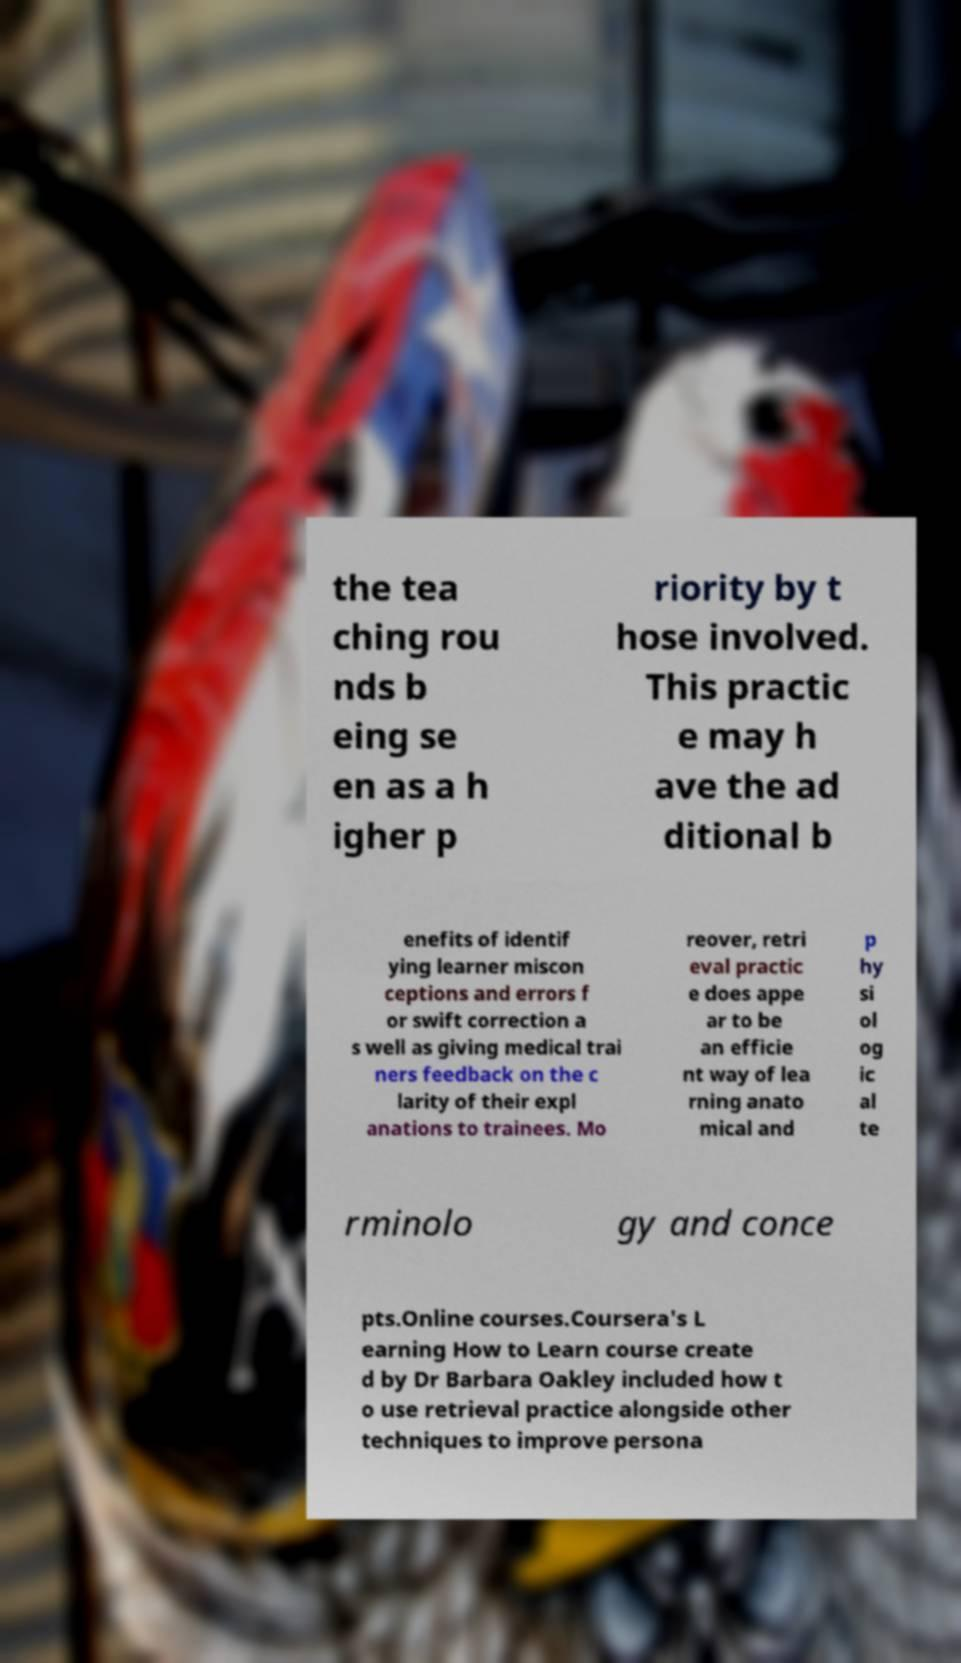Could you extract and type out the text from this image? the tea ching rou nds b eing se en as a h igher p riority by t hose involved. This practic e may h ave the ad ditional b enefits of identif ying learner miscon ceptions and errors f or swift correction a s well as giving medical trai ners feedback on the c larity of their expl anations to trainees. Mo reover, retri eval practic e does appe ar to be an efficie nt way of lea rning anato mical and p hy si ol og ic al te rminolo gy and conce pts.Online courses.Coursera's L earning How to Learn course create d by Dr Barbara Oakley included how t o use retrieval practice alongside other techniques to improve persona 